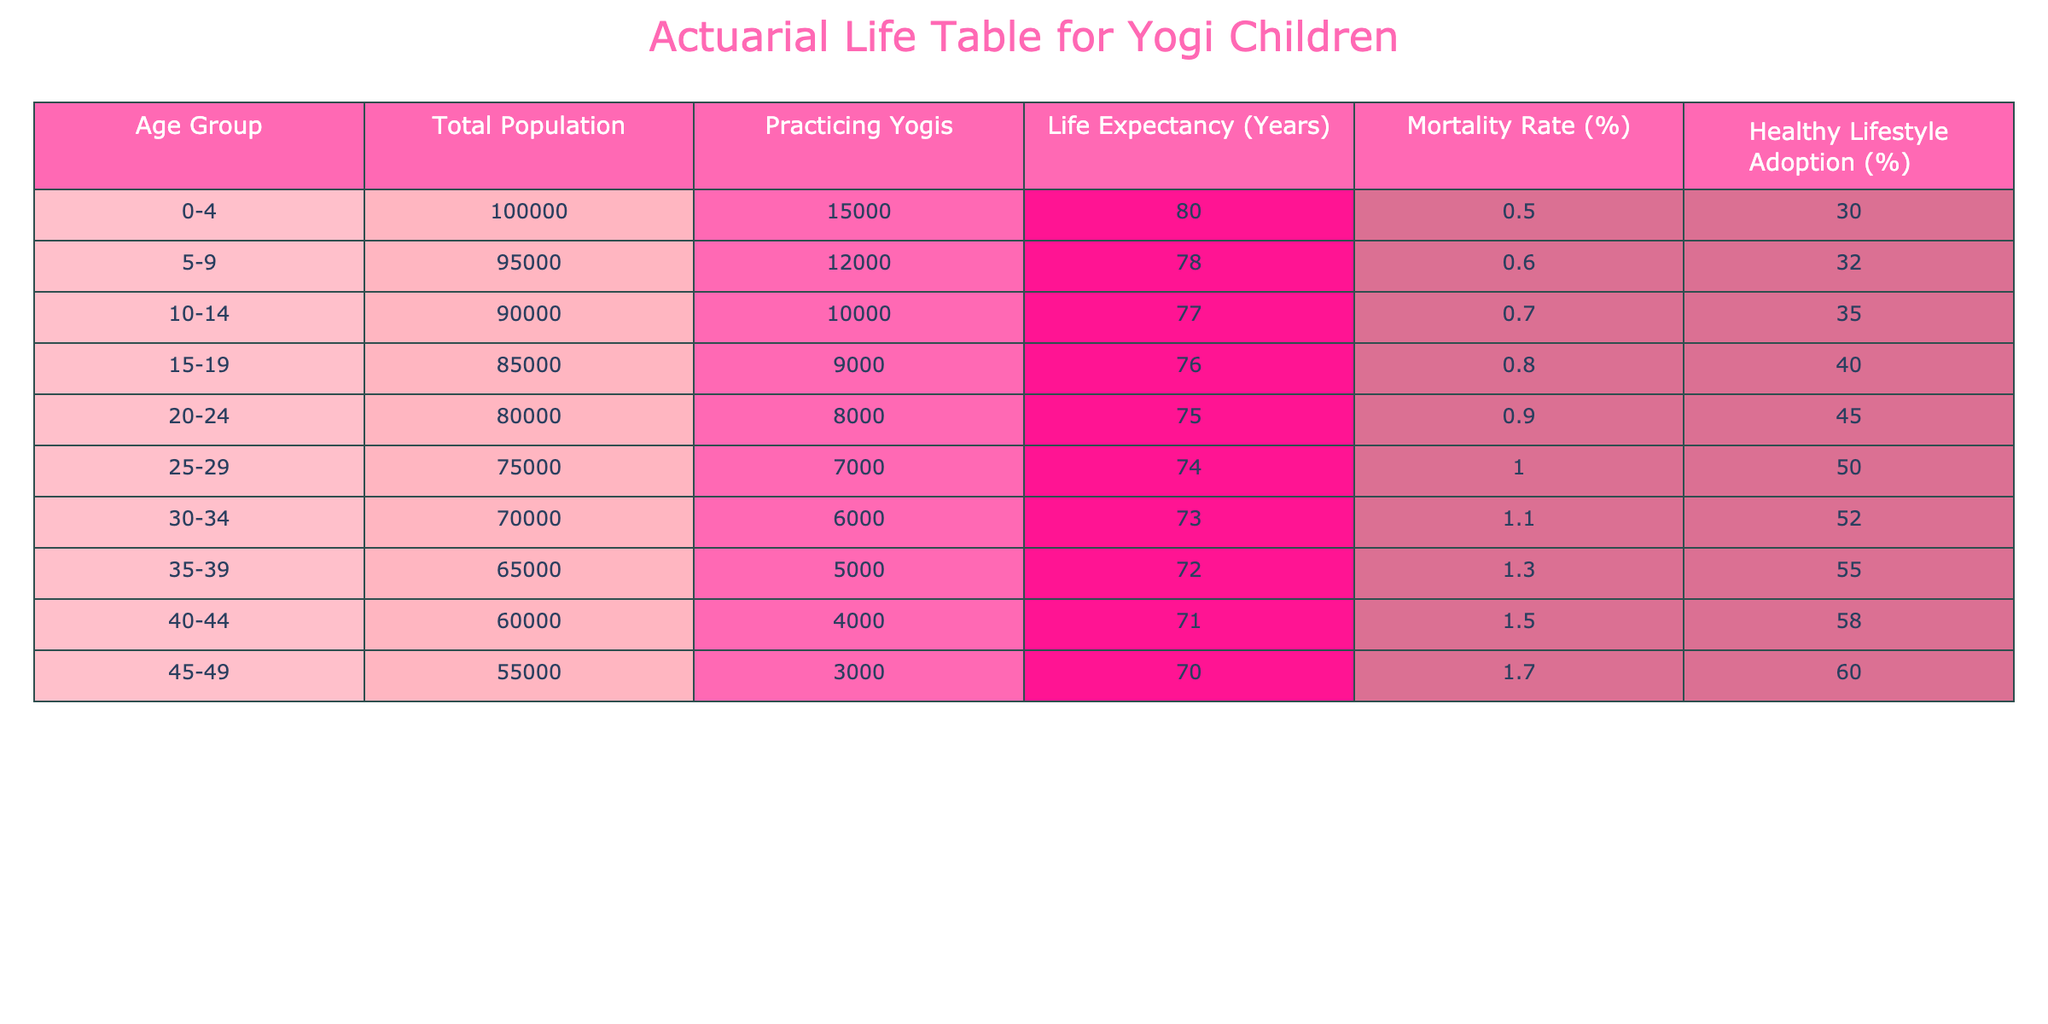What is the life expectancy for children aged 0-4 who practice yoga? From the table, the life expectancy for the age group 0-4 is directly stated as 80 years.
Answer: 80 How many practicing yogis are there in the 15-19 age group? The table shows that in the 15-19 age group, there are 9000 practicing yogis.
Answer: 9000 What is the total population of children in the 30-34 age group? According to the table, the total population in the 30-34 age group is 70000.
Answer: 70000 What is the average life expectancy of children aged 10-14 and 15-19? The life expectancy for 10-14 is 77 years and for 15-19 is 76 years. The average is (77 + 76) / 2 = 76.5 years.
Answer: 76.5 Is the mortality rate for children aged 5-9 greater than that for children aged 10-14? The mortality rate for 5-9 is 0.6% and for 10-14 is 0.7%. Therefore, yes, the mortality rate for 5-9 is less than for 10-14.
Answer: Yes If a child practices yoga regularly, what is the percentage of adopting a healthy lifestyle in the 40-44 age group? The table provides 58% as the percentage of adopting a healthy lifestyle for the 40-44 age group.
Answer: 58% What is the difference in total population between the 0-4 age group and the 25-29 age group? The total population for the 0-4 age group is 100000 and for the 25-29 age group is 75000. The difference is 100000 - 75000 = 25000.
Answer: 25000 Are there more children practicing yoga in the 20-24 age group compared to the 40-44 age group? The 20-24 age group has 8000 practicing yogis, while the 40-44 age group has 4000. Therefore, yes, there are more practicing yogis in the 20-24 age group.
Answer: Yes What is the healthy lifestyle adoption percentage for children aged 35-39? The table states that the healthy lifestyle adoption percentage for the 35-39 age group is 55%.
Answer: 55% 